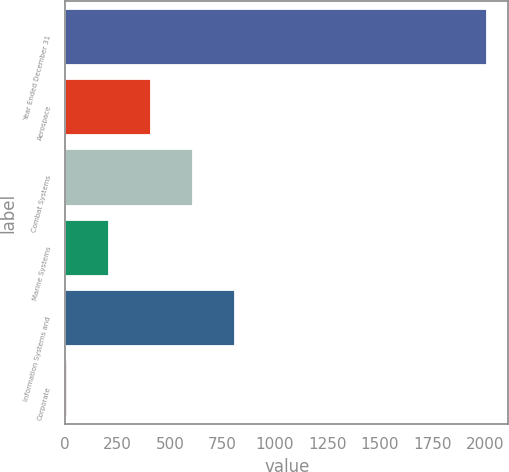<chart> <loc_0><loc_0><loc_500><loc_500><bar_chart><fcel>Year Ended December 31<fcel>Aerospace<fcel>Combat Systems<fcel>Marine Systems<fcel>Information Systems and<fcel>Corporate<nl><fcel>2012<fcel>408<fcel>608.5<fcel>207.5<fcel>809<fcel>7<nl></chart> 